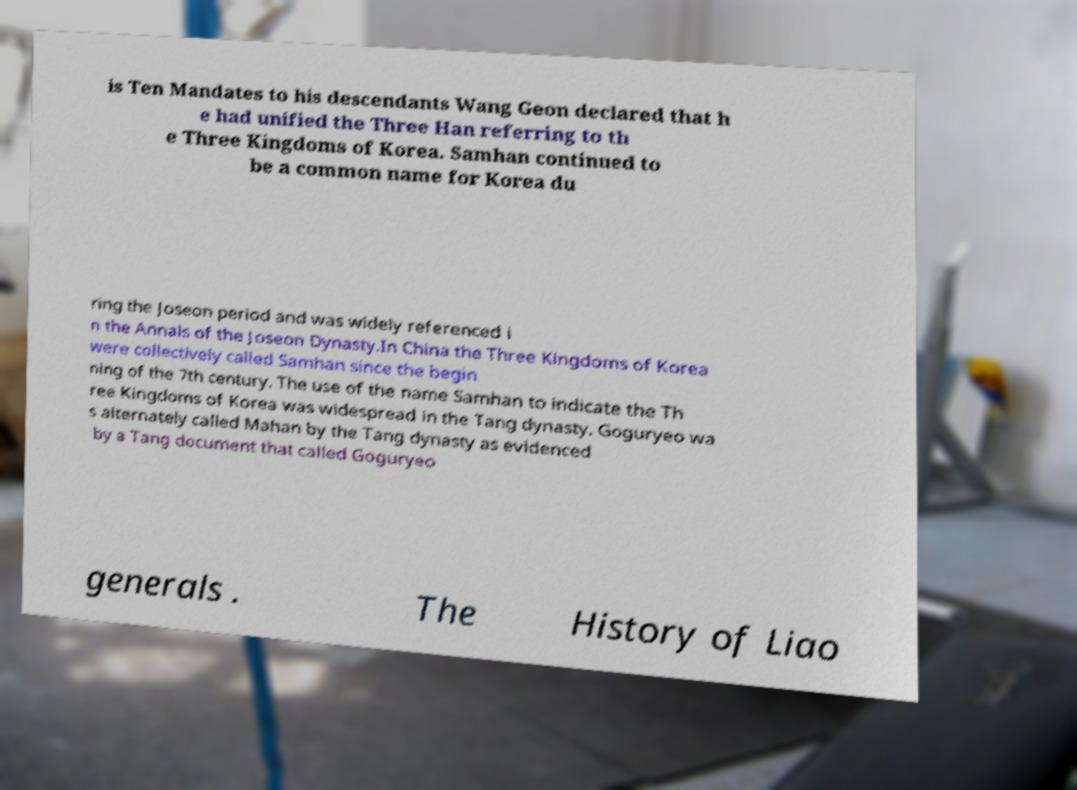For documentation purposes, I need the text within this image transcribed. Could you provide that? is Ten Mandates to his descendants Wang Geon declared that h e had unified the Three Han referring to th e Three Kingdoms of Korea. Samhan continued to be a common name for Korea du ring the Joseon period and was widely referenced i n the Annals of the Joseon Dynasty.In China the Three Kingdoms of Korea were collectively called Samhan since the begin ning of the 7th century. The use of the name Samhan to indicate the Th ree Kingdoms of Korea was widespread in the Tang dynasty. Goguryeo wa s alternately called Mahan by the Tang dynasty as evidenced by a Tang document that called Goguryeo generals . The History of Liao 